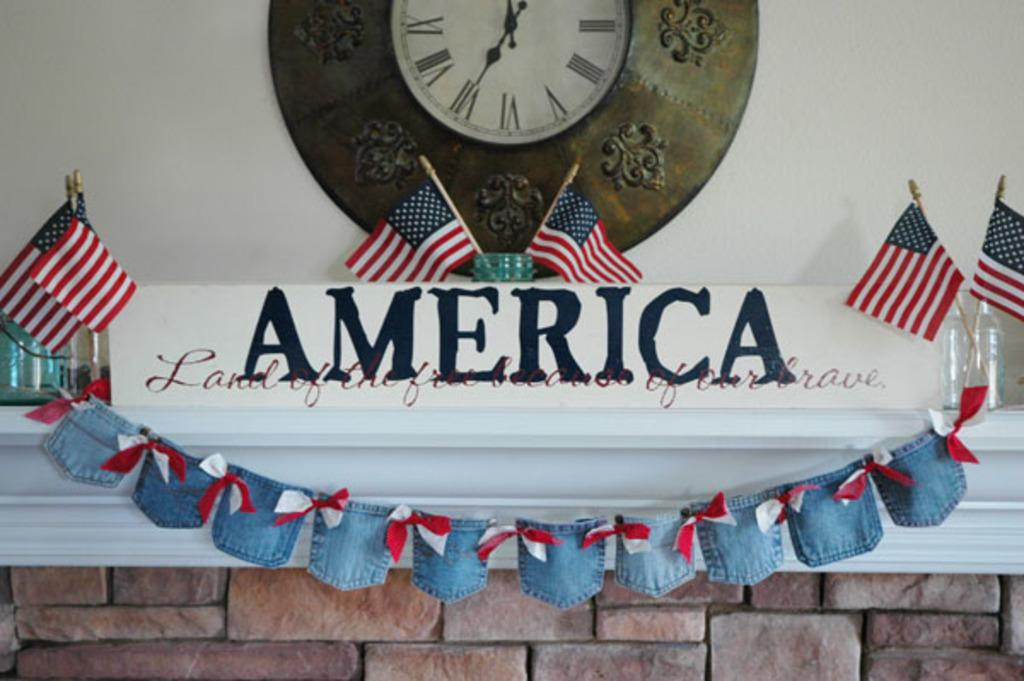Provide a one-sentence caption for the provided image. A fireplace mantle that says America on it surrounded by flags. 